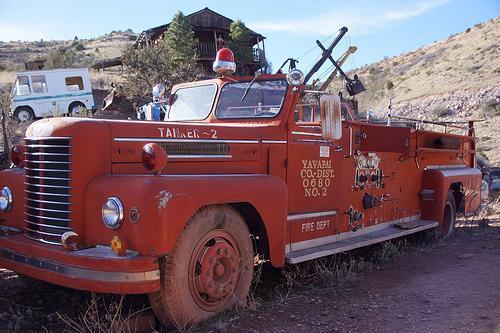How many fire trucks?
Give a very brief answer. 1. 